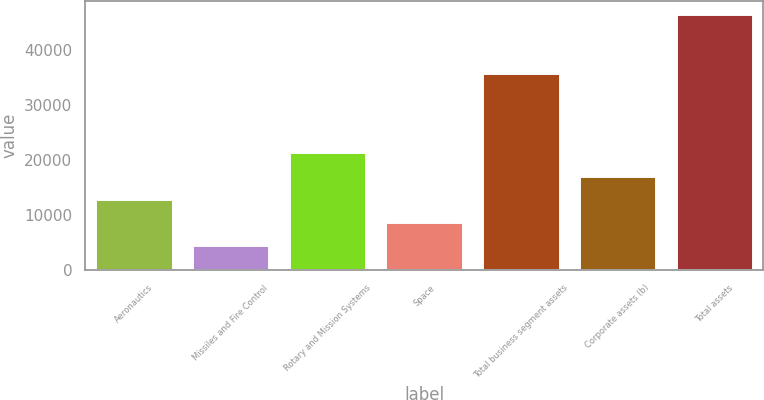Convert chart to OTSL. <chart><loc_0><loc_0><loc_500><loc_500><bar_chart><fcel>Aeronautics<fcel>Missiles and Fire Control<fcel>Rotary and Mission Systems<fcel>Space<fcel>Total business segment assets<fcel>Corporate assets (b)<fcel>Total assets<nl><fcel>12985.6<fcel>4577<fcel>21394.2<fcel>8781.3<fcel>35822<fcel>17189.9<fcel>46620<nl></chart> 